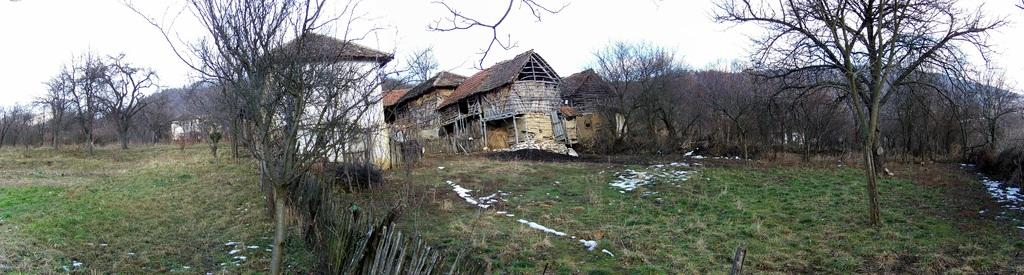What type of vegetation can be seen in the image? There are trees and grass in the image. What type of structures are present in the image? There are houses in the shape of huts in the image. What can be seen in the background of the image? There are mountains and a clear sky in the background of the image. How many cats are sitting on the bridge in the image? There is no bridge or cats present in the image. 